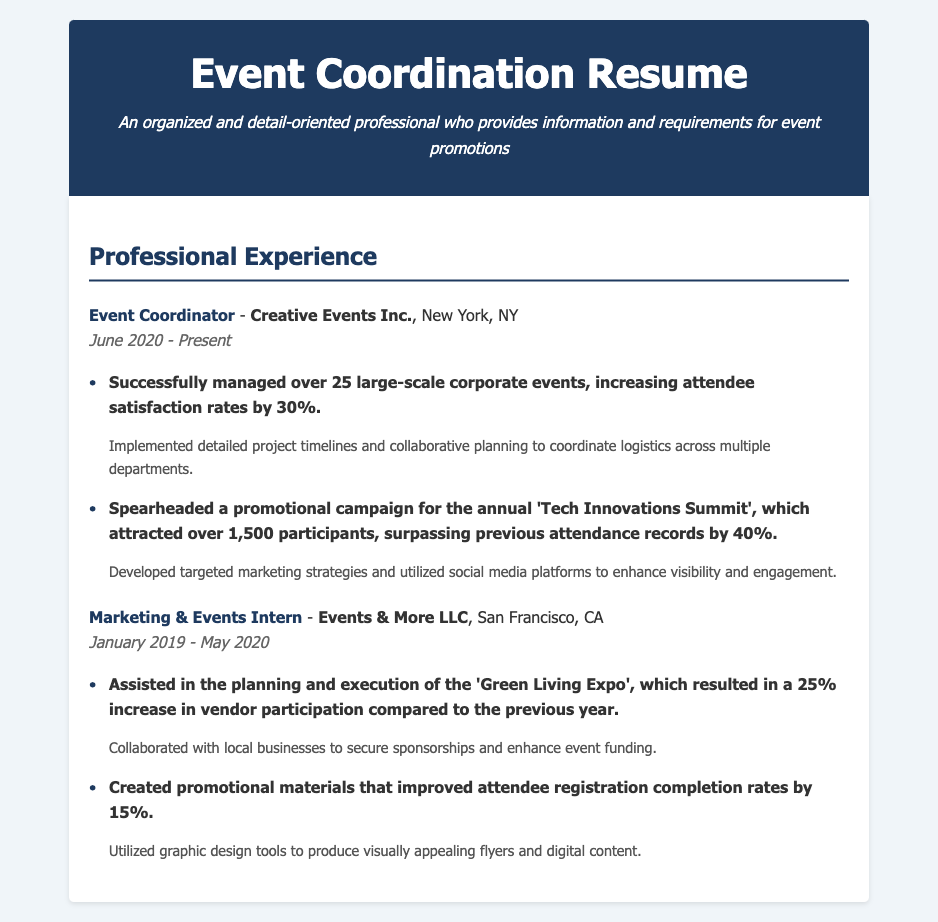What is the title of the current position? The current position indicated in the resume is the title located at the top of the experience section, which is "Event Coordinator."
Answer: Event Coordinator What company is the current position with? The company name is found alongside the job title and location for the current position, which is "Creative Events Inc."
Answer: Creative Events Inc How many large-scale corporate events were managed? The number of large-scale corporate events managed is stated in one of the accomplishments, which is "over 25."
Answer: over 25 What was the increase in attendee satisfaction rates? The increase in attendee satisfaction rates is mentioned in the achievements section as "30%."
Answer: 30% By how much did attendance records exceed for the 'Tech Innovations Summit'? The document indicates that attendance records were surpassed by "40%."
Answer: 40% What was the duration of the Marketing & Events Intern position? The time period for the internship is noted next to the job title, which is "January 2019 - May 2020."
Answer: January 2019 - May 2020 What event resulted in a 25% increase in vendor participation? The event that saw a 25% increase in vendor participation is specifically named as the "Green Living Expo."
Answer: Green Living Expo What was the impact of the promotional materials created during the internship? The impact is quantified in the achievements section of the internship, indicating a "15% increase" in registration completion rates.
Answer: 15% What marketing strategies were used to enhance visibility for the summit? The strategies mentioned for enhancing visibility and engagement can be summarized as "targeted marketing strategies and social media platforms."
Answer: targeted marketing strategies and social media platforms 